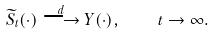Convert formula to latex. <formula><loc_0><loc_0><loc_500><loc_500>\widetilde { S } _ { t } ( \cdot ) \stackrel { d } { \longrightarrow } Y ( \cdot ) , \quad t \to \infty .</formula> 